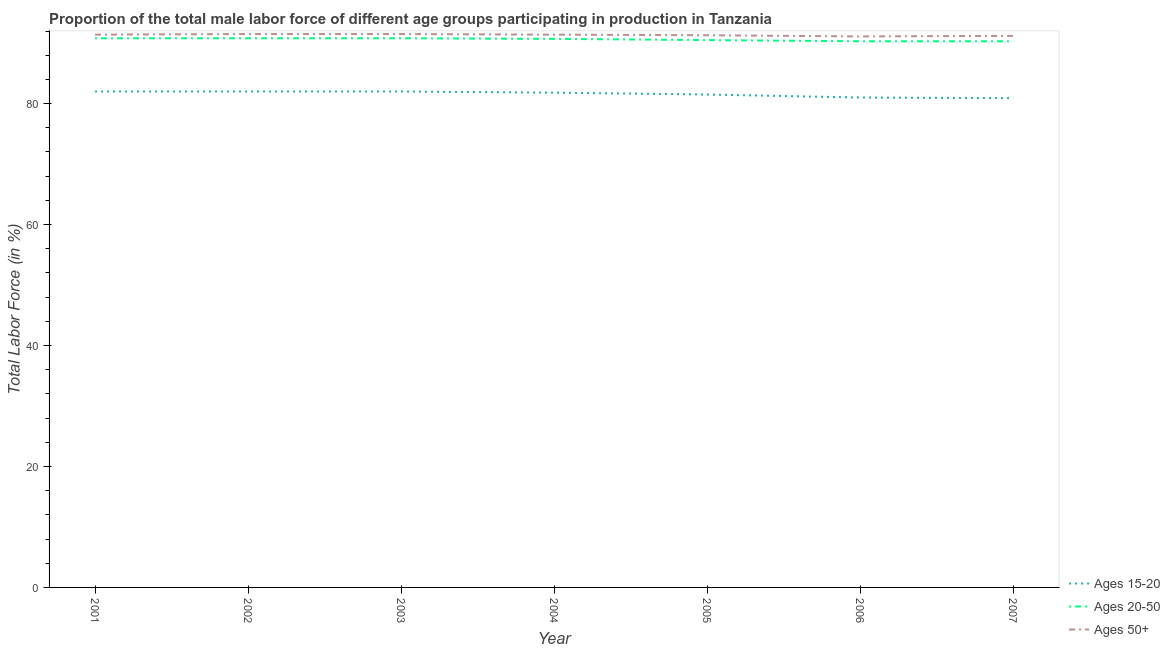Does the line corresponding to percentage of male labor force within the age group 20-50 intersect with the line corresponding to percentage of male labor force above age 50?
Give a very brief answer. No. Is the number of lines equal to the number of legend labels?
Make the answer very short. Yes. What is the percentage of male labor force above age 50 in 2001?
Give a very brief answer. 91.4. Across all years, what is the maximum percentage of male labor force above age 50?
Provide a short and direct response. 91.5. Across all years, what is the minimum percentage of male labor force above age 50?
Provide a short and direct response. 91.1. In which year was the percentage of male labor force within the age group 15-20 maximum?
Make the answer very short. 2001. In which year was the percentage of male labor force above age 50 minimum?
Offer a very short reply. 2006. What is the total percentage of male labor force within the age group 15-20 in the graph?
Ensure brevity in your answer.  571.2. What is the difference between the percentage of male labor force above age 50 in 2003 and that in 2006?
Keep it short and to the point. 0.4. What is the difference between the percentage of male labor force within the age group 20-50 in 2006 and the percentage of male labor force above age 50 in 2001?
Make the answer very short. -1.1. What is the average percentage of male labor force within the age group 20-50 per year?
Provide a short and direct response. 90.6. In the year 2007, what is the difference between the percentage of male labor force within the age group 15-20 and percentage of male labor force above age 50?
Keep it short and to the point. -10.3. In how many years, is the percentage of male labor force within the age group 15-20 greater than 16 %?
Keep it short and to the point. 7. What is the ratio of the percentage of male labor force within the age group 20-50 in 2003 to that in 2006?
Offer a terse response. 1.01. Is the percentage of male labor force within the age group 20-50 in 2003 less than that in 2006?
Ensure brevity in your answer.  No. What is the difference between the highest and the second highest percentage of male labor force above age 50?
Make the answer very short. 0. What is the difference between the highest and the lowest percentage of male labor force above age 50?
Provide a succinct answer. 0.4. Is it the case that in every year, the sum of the percentage of male labor force within the age group 15-20 and percentage of male labor force within the age group 20-50 is greater than the percentage of male labor force above age 50?
Provide a succinct answer. Yes. How many lines are there?
Your answer should be compact. 3. What is the difference between two consecutive major ticks on the Y-axis?
Ensure brevity in your answer.  20. Does the graph contain any zero values?
Your response must be concise. No. Does the graph contain grids?
Offer a terse response. No. Where does the legend appear in the graph?
Keep it short and to the point. Bottom right. How many legend labels are there?
Your response must be concise. 3. What is the title of the graph?
Your answer should be very brief. Proportion of the total male labor force of different age groups participating in production in Tanzania. Does "Gaseous fuel" appear as one of the legend labels in the graph?
Make the answer very short. No. What is the label or title of the Y-axis?
Your response must be concise. Total Labor Force (in %). What is the Total Labor Force (in %) in Ages 20-50 in 2001?
Ensure brevity in your answer.  90.8. What is the Total Labor Force (in %) in Ages 50+ in 2001?
Provide a short and direct response. 91.4. What is the Total Labor Force (in %) in Ages 15-20 in 2002?
Ensure brevity in your answer.  82. What is the Total Labor Force (in %) in Ages 20-50 in 2002?
Offer a very short reply. 90.8. What is the Total Labor Force (in %) in Ages 50+ in 2002?
Keep it short and to the point. 91.5. What is the Total Labor Force (in %) in Ages 15-20 in 2003?
Your response must be concise. 82. What is the Total Labor Force (in %) of Ages 20-50 in 2003?
Your answer should be compact. 90.8. What is the Total Labor Force (in %) in Ages 50+ in 2003?
Ensure brevity in your answer.  91.5. What is the Total Labor Force (in %) in Ages 15-20 in 2004?
Make the answer very short. 81.8. What is the Total Labor Force (in %) of Ages 20-50 in 2004?
Your answer should be very brief. 90.7. What is the Total Labor Force (in %) of Ages 50+ in 2004?
Keep it short and to the point. 91.4. What is the Total Labor Force (in %) in Ages 15-20 in 2005?
Offer a very short reply. 81.5. What is the Total Labor Force (in %) of Ages 20-50 in 2005?
Your response must be concise. 90.5. What is the Total Labor Force (in %) of Ages 50+ in 2005?
Keep it short and to the point. 91.3. What is the Total Labor Force (in %) of Ages 15-20 in 2006?
Your response must be concise. 81. What is the Total Labor Force (in %) in Ages 20-50 in 2006?
Keep it short and to the point. 90.3. What is the Total Labor Force (in %) in Ages 50+ in 2006?
Make the answer very short. 91.1. What is the Total Labor Force (in %) in Ages 15-20 in 2007?
Provide a short and direct response. 80.9. What is the Total Labor Force (in %) in Ages 20-50 in 2007?
Provide a short and direct response. 90.3. What is the Total Labor Force (in %) of Ages 50+ in 2007?
Provide a short and direct response. 91.2. Across all years, what is the maximum Total Labor Force (in %) of Ages 20-50?
Ensure brevity in your answer.  90.8. Across all years, what is the maximum Total Labor Force (in %) in Ages 50+?
Your answer should be compact. 91.5. Across all years, what is the minimum Total Labor Force (in %) of Ages 15-20?
Give a very brief answer. 80.9. Across all years, what is the minimum Total Labor Force (in %) of Ages 20-50?
Give a very brief answer. 90.3. Across all years, what is the minimum Total Labor Force (in %) in Ages 50+?
Give a very brief answer. 91.1. What is the total Total Labor Force (in %) in Ages 15-20 in the graph?
Make the answer very short. 571.2. What is the total Total Labor Force (in %) of Ages 20-50 in the graph?
Your response must be concise. 634.2. What is the total Total Labor Force (in %) of Ages 50+ in the graph?
Offer a very short reply. 639.4. What is the difference between the Total Labor Force (in %) in Ages 50+ in 2001 and that in 2002?
Keep it short and to the point. -0.1. What is the difference between the Total Labor Force (in %) in Ages 50+ in 2001 and that in 2003?
Make the answer very short. -0.1. What is the difference between the Total Labor Force (in %) of Ages 15-20 in 2001 and that in 2004?
Offer a very short reply. 0.2. What is the difference between the Total Labor Force (in %) in Ages 50+ in 2001 and that in 2004?
Provide a short and direct response. 0. What is the difference between the Total Labor Force (in %) in Ages 15-20 in 2001 and that in 2006?
Keep it short and to the point. 1. What is the difference between the Total Labor Force (in %) in Ages 20-50 in 2001 and that in 2006?
Offer a very short reply. 0.5. What is the difference between the Total Labor Force (in %) of Ages 15-20 in 2001 and that in 2007?
Keep it short and to the point. 1.1. What is the difference between the Total Labor Force (in %) of Ages 20-50 in 2001 and that in 2007?
Ensure brevity in your answer.  0.5. What is the difference between the Total Labor Force (in %) of Ages 50+ in 2001 and that in 2007?
Offer a very short reply. 0.2. What is the difference between the Total Labor Force (in %) in Ages 20-50 in 2002 and that in 2003?
Keep it short and to the point. 0. What is the difference between the Total Labor Force (in %) of Ages 50+ in 2002 and that in 2004?
Offer a terse response. 0.1. What is the difference between the Total Labor Force (in %) of Ages 50+ in 2002 and that in 2005?
Your response must be concise. 0.2. What is the difference between the Total Labor Force (in %) in Ages 20-50 in 2002 and that in 2006?
Ensure brevity in your answer.  0.5. What is the difference between the Total Labor Force (in %) in Ages 15-20 in 2002 and that in 2007?
Ensure brevity in your answer.  1.1. What is the difference between the Total Labor Force (in %) in Ages 50+ in 2002 and that in 2007?
Keep it short and to the point. 0.3. What is the difference between the Total Labor Force (in %) in Ages 15-20 in 2003 and that in 2004?
Ensure brevity in your answer.  0.2. What is the difference between the Total Labor Force (in %) in Ages 20-50 in 2003 and that in 2004?
Your answer should be very brief. 0.1. What is the difference between the Total Labor Force (in %) of Ages 50+ in 2003 and that in 2004?
Provide a short and direct response. 0.1. What is the difference between the Total Labor Force (in %) of Ages 15-20 in 2003 and that in 2005?
Offer a terse response. 0.5. What is the difference between the Total Labor Force (in %) in Ages 20-50 in 2003 and that in 2005?
Offer a terse response. 0.3. What is the difference between the Total Labor Force (in %) in Ages 50+ in 2003 and that in 2005?
Ensure brevity in your answer.  0.2. What is the difference between the Total Labor Force (in %) of Ages 20-50 in 2003 and that in 2006?
Your response must be concise. 0.5. What is the difference between the Total Labor Force (in %) in Ages 15-20 in 2003 and that in 2007?
Provide a short and direct response. 1.1. What is the difference between the Total Labor Force (in %) in Ages 20-50 in 2003 and that in 2007?
Make the answer very short. 0.5. What is the difference between the Total Labor Force (in %) in Ages 50+ in 2003 and that in 2007?
Give a very brief answer. 0.3. What is the difference between the Total Labor Force (in %) of Ages 50+ in 2004 and that in 2005?
Your answer should be compact. 0.1. What is the difference between the Total Labor Force (in %) of Ages 50+ in 2004 and that in 2006?
Provide a short and direct response. 0.3. What is the difference between the Total Labor Force (in %) of Ages 20-50 in 2005 and that in 2006?
Keep it short and to the point. 0.2. What is the difference between the Total Labor Force (in %) of Ages 50+ in 2005 and that in 2006?
Your answer should be very brief. 0.2. What is the difference between the Total Labor Force (in %) of Ages 50+ in 2005 and that in 2007?
Make the answer very short. 0.1. What is the difference between the Total Labor Force (in %) of Ages 15-20 in 2006 and that in 2007?
Make the answer very short. 0.1. What is the difference between the Total Labor Force (in %) of Ages 20-50 in 2006 and that in 2007?
Ensure brevity in your answer.  0. What is the difference between the Total Labor Force (in %) in Ages 50+ in 2006 and that in 2007?
Ensure brevity in your answer.  -0.1. What is the difference between the Total Labor Force (in %) of Ages 15-20 in 2001 and the Total Labor Force (in %) of Ages 50+ in 2002?
Your answer should be very brief. -9.5. What is the difference between the Total Labor Force (in %) in Ages 15-20 in 2001 and the Total Labor Force (in %) in Ages 20-50 in 2003?
Give a very brief answer. -8.8. What is the difference between the Total Labor Force (in %) in Ages 15-20 in 2001 and the Total Labor Force (in %) in Ages 50+ in 2003?
Ensure brevity in your answer.  -9.5. What is the difference between the Total Labor Force (in %) of Ages 20-50 in 2001 and the Total Labor Force (in %) of Ages 50+ in 2003?
Provide a succinct answer. -0.7. What is the difference between the Total Labor Force (in %) in Ages 15-20 in 2001 and the Total Labor Force (in %) in Ages 20-50 in 2004?
Offer a very short reply. -8.7. What is the difference between the Total Labor Force (in %) of Ages 20-50 in 2001 and the Total Labor Force (in %) of Ages 50+ in 2004?
Your answer should be compact. -0.6. What is the difference between the Total Labor Force (in %) of Ages 15-20 in 2001 and the Total Labor Force (in %) of Ages 20-50 in 2006?
Provide a succinct answer. -8.3. What is the difference between the Total Labor Force (in %) in Ages 15-20 in 2001 and the Total Labor Force (in %) in Ages 50+ in 2006?
Your response must be concise. -9.1. What is the difference between the Total Labor Force (in %) of Ages 15-20 in 2001 and the Total Labor Force (in %) of Ages 50+ in 2007?
Your answer should be compact. -9.2. What is the difference between the Total Labor Force (in %) in Ages 20-50 in 2002 and the Total Labor Force (in %) in Ages 50+ in 2004?
Your answer should be very brief. -0.6. What is the difference between the Total Labor Force (in %) of Ages 15-20 in 2002 and the Total Labor Force (in %) of Ages 20-50 in 2005?
Offer a very short reply. -8.5. What is the difference between the Total Labor Force (in %) in Ages 15-20 in 2002 and the Total Labor Force (in %) in Ages 50+ in 2005?
Your answer should be very brief. -9.3. What is the difference between the Total Labor Force (in %) of Ages 20-50 in 2002 and the Total Labor Force (in %) of Ages 50+ in 2005?
Your answer should be compact. -0.5. What is the difference between the Total Labor Force (in %) of Ages 20-50 in 2002 and the Total Labor Force (in %) of Ages 50+ in 2006?
Offer a terse response. -0.3. What is the difference between the Total Labor Force (in %) of Ages 15-20 in 2002 and the Total Labor Force (in %) of Ages 50+ in 2007?
Provide a short and direct response. -9.2. What is the difference between the Total Labor Force (in %) of Ages 20-50 in 2002 and the Total Labor Force (in %) of Ages 50+ in 2007?
Your answer should be compact. -0.4. What is the difference between the Total Labor Force (in %) in Ages 15-20 in 2003 and the Total Labor Force (in %) in Ages 50+ in 2004?
Give a very brief answer. -9.4. What is the difference between the Total Labor Force (in %) in Ages 20-50 in 2003 and the Total Labor Force (in %) in Ages 50+ in 2004?
Offer a terse response. -0.6. What is the difference between the Total Labor Force (in %) of Ages 15-20 in 2003 and the Total Labor Force (in %) of Ages 20-50 in 2007?
Your answer should be very brief. -8.3. What is the difference between the Total Labor Force (in %) in Ages 20-50 in 2003 and the Total Labor Force (in %) in Ages 50+ in 2007?
Your response must be concise. -0.4. What is the difference between the Total Labor Force (in %) in Ages 15-20 in 2004 and the Total Labor Force (in %) in Ages 50+ in 2005?
Your answer should be compact. -9.5. What is the difference between the Total Labor Force (in %) of Ages 15-20 in 2004 and the Total Labor Force (in %) of Ages 20-50 in 2006?
Give a very brief answer. -8.5. What is the difference between the Total Labor Force (in %) of Ages 15-20 in 2004 and the Total Labor Force (in %) of Ages 50+ in 2006?
Ensure brevity in your answer.  -9.3. What is the difference between the Total Labor Force (in %) in Ages 15-20 in 2004 and the Total Labor Force (in %) in Ages 20-50 in 2007?
Make the answer very short. -8.5. What is the difference between the Total Labor Force (in %) of Ages 15-20 in 2004 and the Total Labor Force (in %) of Ages 50+ in 2007?
Your answer should be compact. -9.4. What is the difference between the Total Labor Force (in %) in Ages 15-20 in 2005 and the Total Labor Force (in %) in Ages 20-50 in 2006?
Make the answer very short. -8.8. What is the difference between the Total Labor Force (in %) of Ages 20-50 in 2005 and the Total Labor Force (in %) of Ages 50+ in 2006?
Provide a short and direct response. -0.6. What is the difference between the Total Labor Force (in %) of Ages 15-20 in 2005 and the Total Labor Force (in %) of Ages 20-50 in 2007?
Your response must be concise. -8.8. What is the difference between the Total Labor Force (in %) in Ages 15-20 in 2005 and the Total Labor Force (in %) in Ages 50+ in 2007?
Your answer should be compact. -9.7. What is the difference between the Total Labor Force (in %) in Ages 15-20 in 2006 and the Total Labor Force (in %) in Ages 20-50 in 2007?
Provide a short and direct response. -9.3. What is the difference between the Total Labor Force (in %) of Ages 20-50 in 2006 and the Total Labor Force (in %) of Ages 50+ in 2007?
Offer a terse response. -0.9. What is the average Total Labor Force (in %) in Ages 15-20 per year?
Provide a succinct answer. 81.6. What is the average Total Labor Force (in %) in Ages 20-50 per year?
Offer a terse response. 90.6. What is the average Total Labor Force (in %) in Ages 50+ per year?
Offer a terse response. 91.34. In the year 2001, what is the difference between the Total Labor Force (in %) in Ages 20-50 and Total Labor Force (in %) in Ages 50+?
Make the answer very short. -0.6. In the year 2002, what is the difference between the Total Labor Force (in %) of Ages 15-20 and Total Labor Force (in %) of Ages 20-50?
Make the answer very short. -8.8. In the year 2002, what is the difference between the Total Labor Force (in %) in Ages 15-20 and Total Labor Force (in %) in Ages 50+?
Provide a short and direct response. -9.5. In the year 2003, what is the difference between the Total Labor Force (in %) of Ages 15-20 and Total Labor Force (in %) of Ages 50+?
Your response must be concise. -9.5. In the year 2004, what is the difference between the Total Labor Force (in %) of Ages 20-50 and Total Labor Force (in %) of Ages 50+?
Make the answer very short. -0.7. In the year 2005, what is the difference between the Total Labor Force (in %) of Ages 15-20 and Total Labor Force (in %) of Ages 20-50?
Your answer should be very brief. -9. In the year 2005, what is the difference between the Total Labor Force (in %) of Ages 20-50 and Total Labor Force (in %) of Ages 50+?
Your answer should be very brief. -0.8. In the year 2006, what is the difference between the Total Labor Force (in %) in Ages 15-20 and Total Labor Force (in %) in Ages 50+?
Your answer should be very brief. -10.1. In the year 2006, what is the difference between the Total Labor Force (in %) of Ages 20-50 and Total Labor Force (in %) of Ages 50+?
Offer a terse response. -0.8. In the year 2007, what is the difference between the Total Labor Force (in %) of Ages 15-20 and Total Labor Force (in %) of Ages 50+?
Make the answer very short. -10.3. In the year 2007, what is the difference between the Total Labor Force (in %) of Ages 20-50 and Total Labor Force (in %) of Ages 50+?
Your answer should be compact. -0.9. What is the ratio of the Total Labor Force (in %) of Ages 15-20 in 2001 to that in 2002?
Offer a terse response. 1. What is the ratio of the Total Labor Force (in %) of Ages 15-20 in 2001 to that in 2003?
Provide a short and direct response. 1. What is the ratio of the Total Labor Force (in %) in Ages 50+ in 2001 to that in 2003?
Give a very brief answer. 1. What is the ratio of the Total Labor Force (in %) in Ages 15-20 in 2001 to that in 2004?
Provide a succinct answer. 1. What is the ratio of the Total Labor Force (in %) of Ages 20-50 in 2001 to that in 2005?
Your response must be concise. 1. What is the ratio of the Total Labor Force (in %) of Ages 15-20 in 2001 to that in 2006?
Your answer should be very brief. 1.01. What is the ratio of the Total Labor Force (in %) in Ages 20-50 in 2001 to that in 2006?
Your answer should be compact. 1.01. What is the ratio of the Total Labor Force (in %) of Ages 15-20 in 2001 to that in 2007?
Offer a terse response. 1.01. What is the ratio of the Total Labor Force (in %) of Ages 50+ in 2001 to that in 2007?
Your answer should be very brief. 1. What is the ratio of the Total Labor Force (in %) of Ages 20-50 in 2002 to that in 2003?
Offer a very short reply. 1. What is the ratio of the Total Labor Force (in %) of Ages 15-20 in 2002 to that in 2004?
Ensure brevity in your answer.  1. What is the ratio of the Total Labor Force (in %) in Ages 15-20 in 2002 to that in 2005?
Your response must be concise. 1.01. What is the ratio of the Total Labor Force (in %) in Ages 50+ in 2002 to that in 2005?
Make the answer very short. 1. What is the ratio of the Total Labor Force (in %) of Ages 15-20 in 2002 to that in 2006?
Offer a very short reply. 1.01. What is the ratio of the Total Labor Force (in %) of Ages 15-20 in 2002 to that in 2007?
Ensure brevity in your answer.  1.01. What is the ratio of the Total Labor Force (in %) in Ages 20-50 in 2002 to that in 2007?
Your answer should be very brief. 1.01. What is the ratio of the Total Labor Force (in %) of Ages 50+ in 2002 to that in 2007?
Your response must be concise. 1. What is the ratio of the Total Labor Force (in %) in Ages 20-50 in 2003 to that in 2004?
Keep it short and to the point. 1. What is the ratio of the Total Labor Force (in %) of Ages 20-50 in 2003 to that in 2005?
Make the answer very short. 1. What is the ratio of the Total Labor Force (in %) of Ages 50+ in 2003 to that in 2005?
Offer a very short reply. 1. What is the ratio of the Total Labor Force (in %) of Ages 15-20 in 2003 to that in 2006?
Offer a terse response. 1.01. What is the ratio of the Total Labor Force (in %) of Ages 15-20 in 2003 to that in 2007?
Your answer should be very brief. 1.01. What is the ratio of the Total Labor Force (in %) of Ages 20-50 in 2003 to that in 2007?
Offer a very short reply. 1.01. What is the ratio of the Total Labor Force (in %) of Ages 50+ in 2003 to that in 2007?
Your answer should be compact. 1. What is the ratio of the Total Labor Force (in %) of Ages 20-50 in 2004 to that in 2005?
Ensure brevity in your answer.  1. What is the ratio of the Total Labor Force (in %) of Ages 50+ in 2004 to that in 2005?
Provide a succinct answer. 1. What is the ratio of the Total Labor Force (in %) of Ages 15-20 in 2004 to that in 2006?
Your answer should be compact. 1.01. What is the ratio of the Total Labor Force (in %) of Ages 15-20 in 2004 to that in 2007?
Offer a terse response. 1.01. What is the ratio of the Total Labor Force (in %) of Ages 50+ in 2004 to that in 2007?
Offer a terse response. 1. What is the ratio of the Total Labor Force (in %) in Ages 50+ in 2005 to that in 2006?
Ensure brevity in your answer.  1. What is the ratio of the Total Labor Force (in %) in Ages 15-20 in 2005 to that in 2007?
Give a very brief answer. 1.01. What is the ratio of the Total Labor Force (in %) in Ages 50+ in 2005 to that in 2007?
Ensure brevity in your answer.  1. What is the ratio of the Total Labor Force (in %) of Ages 20-50 in 2006 to that in 2007?
Offer a very short reply. 1. What is the ratio of the Total Labor Force (in %) in Ages 50+ in 2006 to that in 2007?
Make the answer very short. 1. What is the difference between the highest and the second highest Total Labor Force (in %) in Ages 15-20?
Your answer should be compact. 0. What is the difference between the highest and the second highest Total Labor Force (in %) of Ages 20-50?
Offer a very short reply. 0. What is the difference between the highest and the second highest Total Labor Force (in %) in Ages 50+?
Provide a succinct answer. 0. What is the difference between the highest and the lowest Total Labor Force (in %) of Ages 50+?
Offer a very short reply. 0.4. 